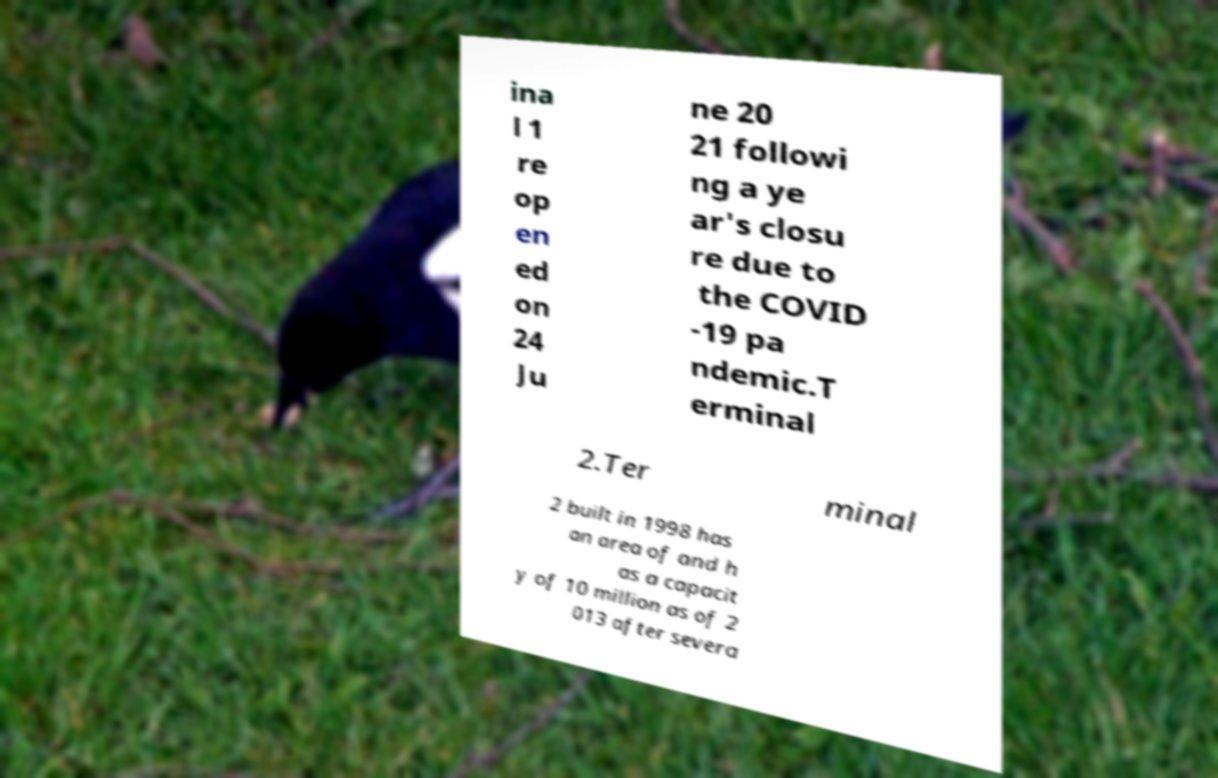I need the written content from this picture converted into text. Can you do that? ina l 1 re op en ed on 24 Ju ne 20 21 followi ng a ye ar's closu re due to the COVID -19 pa ndemic.T erminal 2.Ter minal 2 built in 1998 has an area of and h as a capacit y of 10 million as of 2 013 after severa 